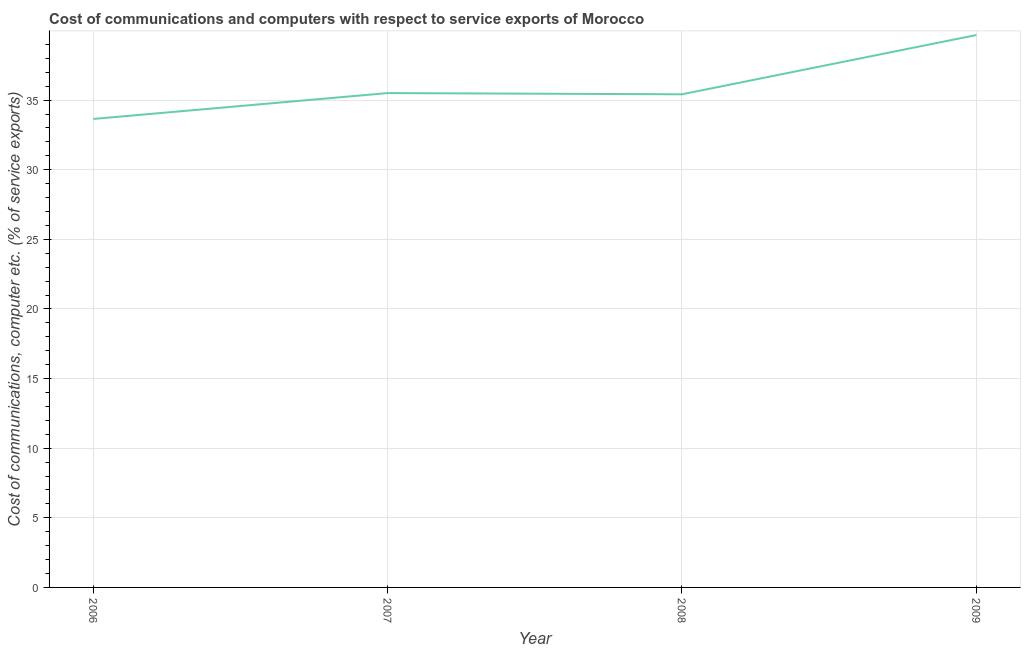What is the cost of communications and computer in 2008?
Provide a short and direct response. 35.42. Across all years, what is the maximum cost of communications and computer?
Offer a very short reply. 39.68. Across all years, what is the minimum cost of communications and computer?
Offer a very short reply. 33.65. In which year was the cost of communications and computer minimum?
Your response must be concise. 2006. What is the sum of the cost of communications and computer?
Your answer should be very brief. 144.26. What is the difference between the cost of communications and computer in 2008 and 2009?
Offer a terse response. -4.26. What is the average cost of communications and computer per year?
Provide a succinct answer. 36.06. What is the median cost of communications and computer?
Your answer should be very brief. 35.46. In how many years, is the cost of communications and computer greater than 4 %?
Provide a short and direct response. 4. What is the ratio of the cost of communications and computer in 2006 to that in 2007?
Provide a succinct answer. 0.95. Is the difference between the cost of communications and computer in 2007 and 2009 greater than the difference between any two years?
Provide a short and direct response. No. What is the difference between the highest and the second highest cost of communications and computer?
Your answer should be very brief. 4.17. What is the difference between the highest and the lowest cost of communications and computer?
Provide a short and direct response. 6.03. How many lines are there?
Provide a short and direct response. 1. How many years are there in the graph?
Ensure brevity in your answer.  4. What is the difference between two consecutive major ticks on the Y-axis?
Keep it short and to the point. 5. What is the title of the graph?
Keep it short and to the point. Cost of communications and computers with respect to service exports of Morocco. What is the label or title of the X-axis?
Give a very brief answer. Year. What is the label or title of the Y-axis?
Ensure brevity in your answer.  Cost of communications, computer etc. (% of service exports). What is the Cost of communications, computer etc. (% of service exports) in 2006?
Keep it short and to the point. 33.65. What is the Cost of communications, computer etc. (% of service exports) of 2007?
Provide a short and direct response. 35.51. What is the Cost of communications, computer etc. (% of service exports) of 2008?
Your answer should be very brief. 35.42. What is the Cost of communications, computer etc. (% of service exports) in 2009?
Provide a succinct answer. 39.68. What is the difference between the Cost of communications, computer etc. (% of service exports) in 2006 and 2007?
Your response must be concise. -1.86. What is the difference between the Cost of communications, computer etc. (% of service exports) in 2006 and 2008?
Make the answer very short. -1.77. What is the difference between the Cost of communications, computer etc. (% of service exports) in 2006 and 2009?
Offer a very short reply. -6.03. What is the difference between the Cost of communications, computer etc. (% of service exports) in 2007 and 2008?
Keep it short and to the point. 0.09. What is the difference between the Cost of communications, computer etc. (% of service exports) in 2007 and 2009?
Make the answer very short. -4.17. What is the difference between the Cost of communications, computer etc. (% of service exports) in 2008 and 2009?
Your response must be concise. -4.26. What is the ratio of the Cost of communications, computer etc. (% of service exports) in 2006 to that in 2007?
Your answer should be compact. 0.95. What is the ratio of the Cost of communications, computer etc. (% of service exports) in 2006 to that in 2008?
Make the answer very short. 0.95. What is the ratio of the Cost of communications, computer etc. (% of service exports) in 2006 to that in 2009?
Your answer should be very brief. 0.85. What is the ratio of the Cost of communications, computer etc. (% of service exports) in 2007 to that in 2009?
Offer a terse response. 0.9. What is the ratio of the Cost of communications, computer etc. (% of service exports) in 2008 to that in 2009?
Provide a succinct answer. 0.89. 